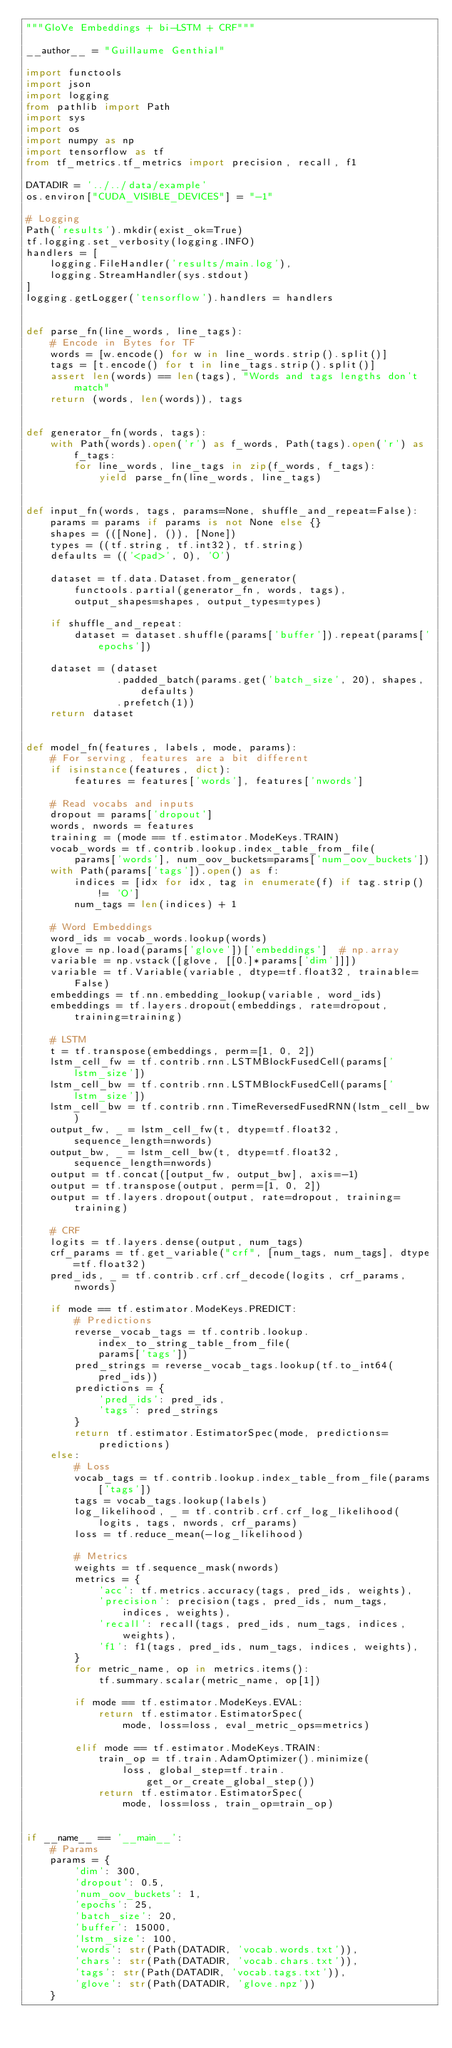Convert code to text. <code><loc_0><loc_0><loc_500><loc_500><_Python_>"""GloVe Embeddings + bi-LSTM + CRF"""

__author__ = "Guillaume Genthial"

import functools
import json
import logging
from pathlib import Path
import sys
import os
import numpy as np
import tensorflow as tf
from tf_metrics.tf_metrics import precision, recall, f1

DATADIR = '../../data/example'
os.environ["CUDA_VISIBLE_DEVICES"] = "-1"

# Logging
Path('results').mkdir(exist_ok=True)
tf.logging.set_verbosity(logging.INFO)
handlers = [
    logging.FileHandler('results/main.log'),
    logging.StreamHandler(sys.stdout)
]
logging.getLogger('tensorflow').handlers = handlers


def parse_fn(line_words, line_tags):
    # Encode in Bytes for TF
    words = [w.encode() for w in line_words.strip().split()]
    tags = [t.encode() for t in line_tags.strip().split()]
    assert len(words) == len(tags), "Words and tags lengths don't match"
    return (words, len(words)), tags


def generator_fn(words, tags):
    with Path(words).open('r') as f_words, Path(tags).open('r') as f_tags:
        for line_words, line_tags in zip(f_words, f_tags):
            yield parse_fn(line_words, line_tags)


def input_fn(words, tags, params=None, shuffle_and_repeat=False):
    params = params if params is not None else {}
    shapes = (([None], ()), [None])
    types = ((tf.string, tf.int32), tf.string)
    defaults = (('<pad>', 0), 'O')

    dataset = tf.data.Dataset.from_generator(
        functools.partial(generator_fn, words, tags),
        output_shapes=shapes, output_types=types)

    if shuffle_and_repeat:
        dataset = dataset.shuffle(params['buffer']).repeat(params['epochs'])

    dataset = (dataset
               .padded_batch(params.get('batch_size', 20), shapes, defaults)
               .prefetch(1))
    return dataset


def model_fn(features, labels, mode, params):
    # For serving, features are a bit different
    if isinstance(features, dict):
        features = features['words'], features['nwords']

    # Read vocabs and inputs
    dropout = params['dropout']
    words, nwords = features
    training = (mode == tf.estimator.ModeKeys.TRAIN)
    vocab_words = tf.contrib.lookup.index_table_from_file(
        params['words'], num_oov_buckets=params['num_oov_buckets'])
    with Path(params['tags']).open() as f:
        indices = [idx for idx, tag in enumerate(f) if tag.strip() != 'O']
        num_tags = len(indices) + 1

    # Word Embeddings
    word_ids = vocab_words.lookup(words)
    glove = np.load(params['glove'])['embeddings']  # np.array
    variable = np.vstack([glove, [[0.]*params['dim']]])
    variable = tf.Variable(variable, dtype=tf.float32, trainable=False)
    embeddings = tf.nn.embedding_lookup(variable, word_ids)
    embeddings = tf.layers.dropout(embeddings, rate=dropout, training=training)

    # LSTM
    t = tf.transpose(embeddings, perm=[1, 0, 2])
    lstm_cell_fw = tf.contrib.rnn.LSTMBlockFusedCell(params['lstm_size'])
    lstm_cell_bw = tf.contrib.rnn.LSTMBlockFusedCell(params['lstm_size'])
    lstm_cell_bw = tf.contrib.rnn.TimeReversedFusedRNN(lstm_cell_bw)
    output_fw, _ = lstm_cell_fw(t, dtype=tf.float32, sequence_length=nwords)
    output_bw, _ = lstm_cell_bw(t, dtype=tf.float32, sequence_length=nwords)
    output = tf.concat([output_fw, output_bw], axis=-1)
    output = tf.transpose(output, perm=[1, 0, 2])
    output = tf.layers.dropout(output, rate=dropout, training=training)

    # CRF
    logits = tf.layers.dense(output, num_tags)
    crf_params = tf.get_variable("crf", [num_tags, num_tags], dtype=tf.float32)
    pred_ids, _ = tf.contrib.crf.crf_decode(logits, crf_params, nwords)

    if mode == tf.estimator.ModeKeys.PREDICT:
        # Predictions
        reverse_vocab_tags = tf.contrib.lookup.index_to_string_table_from_file(
            params['tags'])
        pred_strings = reverse_vocab_tags.lookup(tf.to_int64(pred_ids))
        predictions = {
            'pred_ids': pred_ids,
            'tags': pred_strings
        }
        return tf.estimator.EstimatorSpec(mode, predictions=predictions)
    else:
        # Loss
        vocab_tags = tf.contrib.lookup.index_table_from_file(params['tags'])
        tags = vocab_tags.lookup(labels)
        log_likelihood, _ = tf.contrib.crf.crf_log_likelihood(
            logits, tags, nwords, crf_params)
        loss = tf.reduce_mean(-log_likelihood)

        # Metrics
        weights = tf.sequence_mask(nwords)
        metrics = {
            'acc': tf.metrics.accuracy(tags, pred_ids, weights),
            'precision': precision(tags, pred_ids, num_tags, indices, weights),
            'recall': recall(tags, pred_ids, num_tags, indices, weights),
            'f1': f1(tags, pred_ids, num_tags, indices, weights),
        }
        for metric_name, op in metrics.items():
            tf.summary.scalar(metric_name, op[1])

        if mode == tf.estimator.ModeKeys.EVAL:
            return tf.estimator.EstimatorSpec(
                mode, loss=loss, eval_metric_ops=metrics)

        elif mode == tf.estimator.ModeKeys.TRAIN:
            train_op = tf.train.AdamOptimizer().minimize(
                loss, global_step=tf.train.get_or_create_global_step())
            return tf.estimator.EstimatorSpec(
                mode, loss=loss, train_op=train_op)


if __name__ == '__main__':
    # Params
    params = {
        'dim': 300,
        'dropout': 0.5,
        'num_oov_buckets': 1,
        'epochs': 25,
        'batch_size': 20,
        'buffer': 15000,
        'lstm_size': 100,
        'words': str(Path(DATADIR, 'vocab.words.txt')),
        'chars': str(Path(DATADIR, 'vocab.chars.txt')),
        'tags': str(Path(DATADIR, 'vocab.tags.txt')),
        'glove': str(Path(DATADIR, 'glove.npz'))
    }</code> 